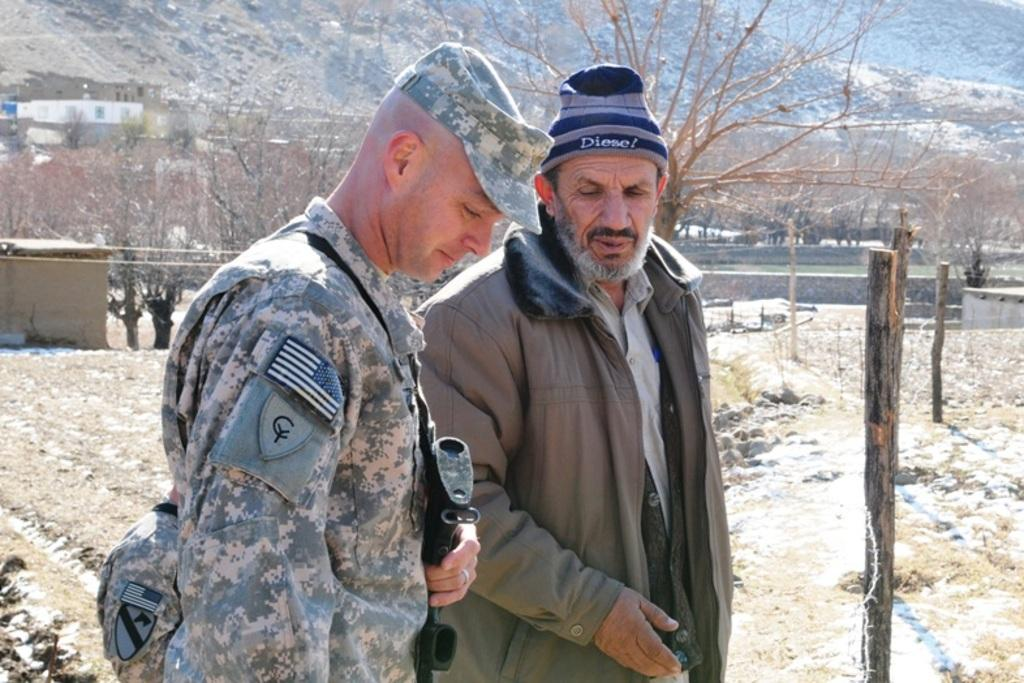How many persons are present in the image? There are two persons in the image. What objects can be seen in the image besides the persons? There are wooden sticks, trees, buildings, and a wall visible in the image. What type of pizzas can be seen on the roof in the image? There are no pizzas present in the image, and there is no mention of a roof. How many sheep are visible in the image? There are no sheep present in the image. 